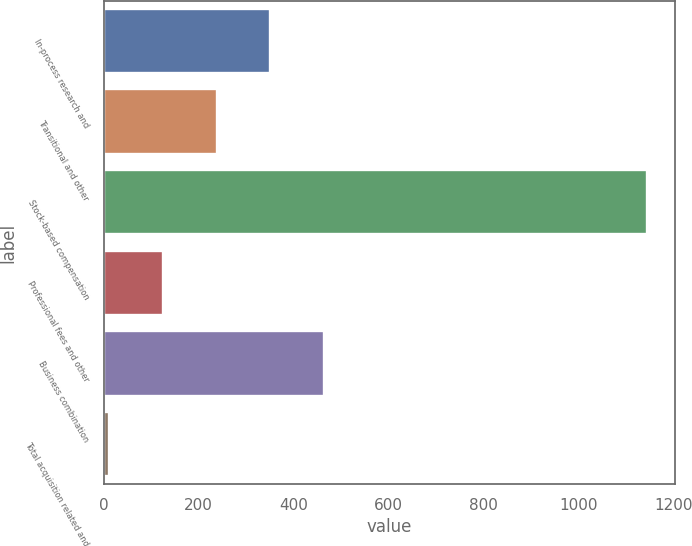Convert chart. <chart><loc_0><loc_0><loc_500><loc_500><bar_chart><fcel>In-process research and<fcel>Transitional and other<fcel>Stock-based compensation<fcel>Professional fees and other<fcel>Business combination<fcel>Total acquisition related and<nl><fcel>350.9<fcel>237.6<fcel>1144<fcel>124.3<fcel>464.2<fcel>11<nl></chart> 